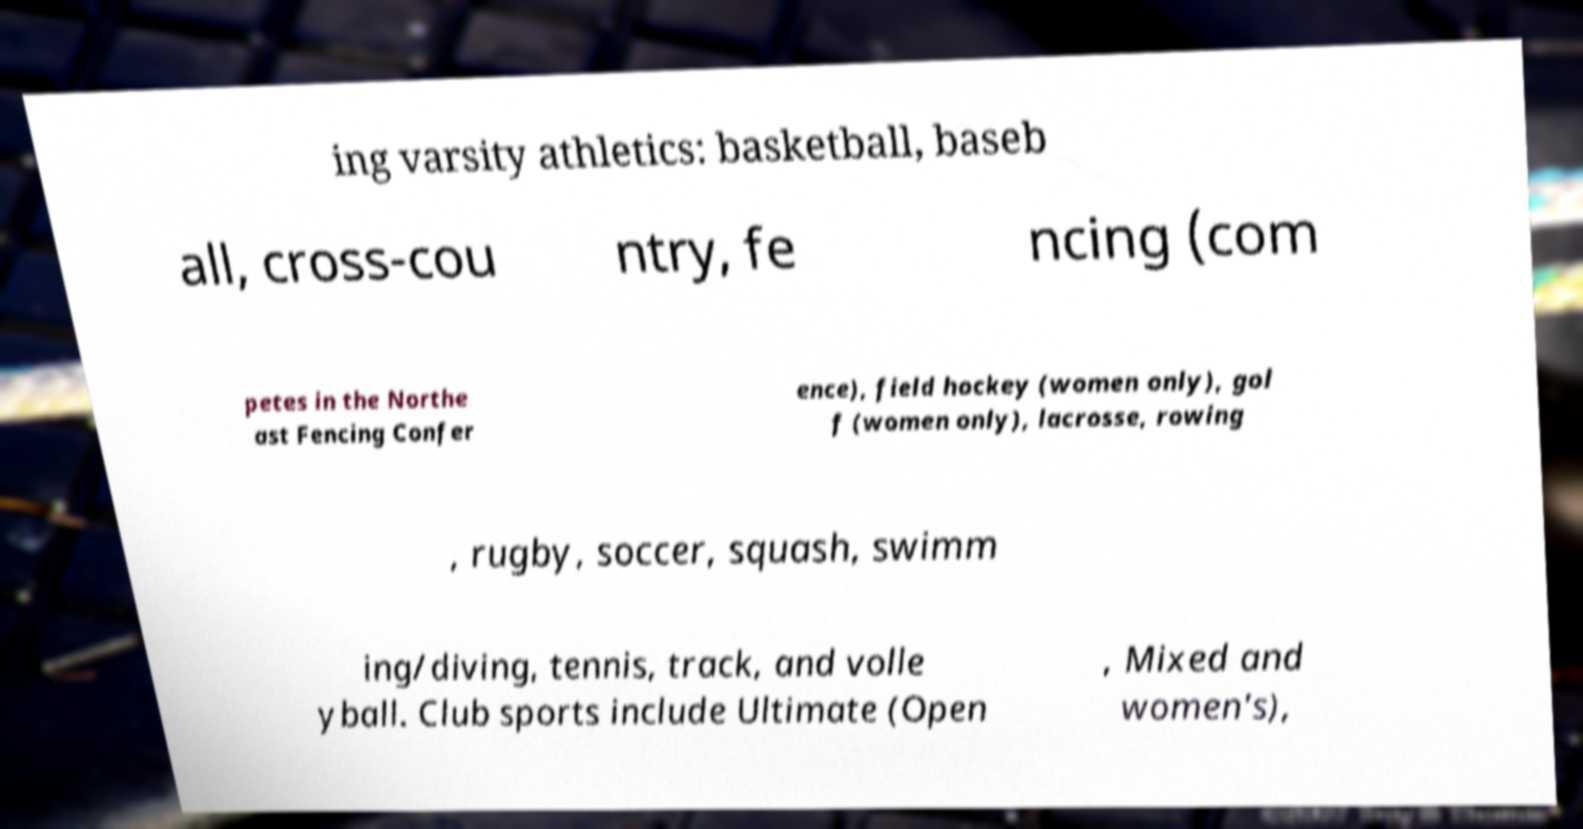Can you accurately transcribe the text from the provided image for me? ing varsity athletics: basketball, baseb all, cross-cou ntry, fe ncing (com petes in the Northe ast Fencing Confer ence), field hockey (women only), gol f (women only), lacrosse, rowing , rugby, soccer, squash, swimm ing/diving, tennis, track, and volle yball. Club sports include Ultimate (Open , Mixed and women's), 